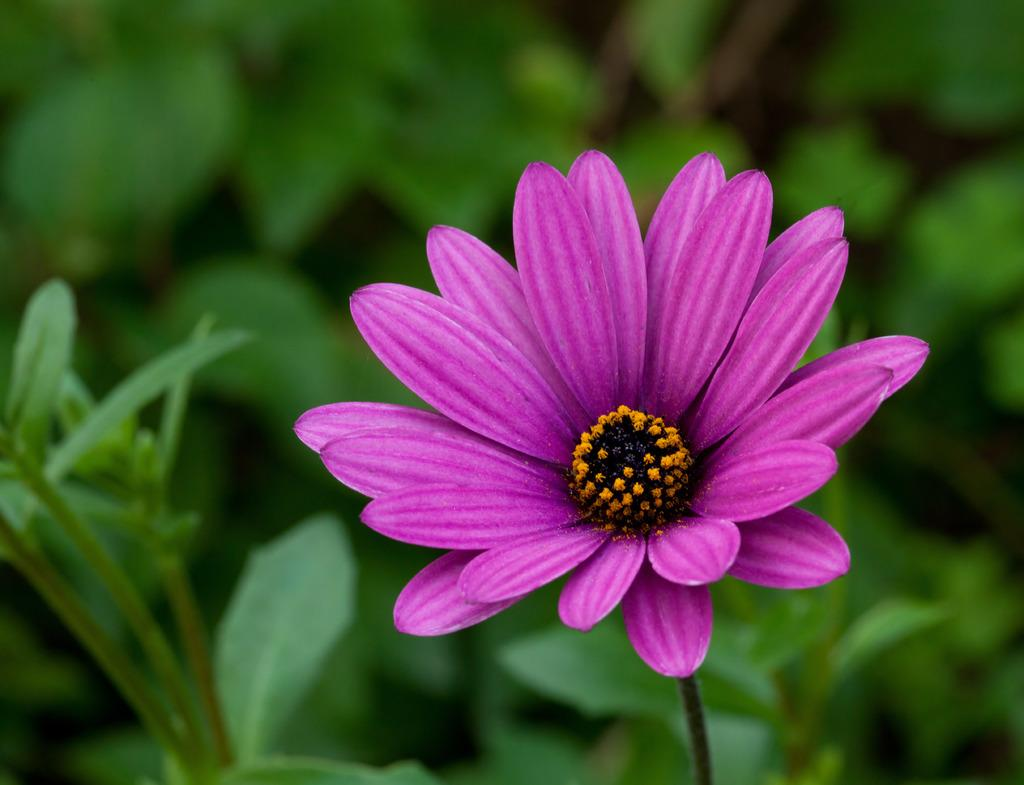What is the main subject in the foreground of the image? There is a flower in the foreground of the image. What can be seen in the background of the image? There are plants in the background of the image. What type of fruit is hanging from the flower in the image? There is no fruit hanging from the flower in the image. What level of security is present in the image? There is no mention of security or a prison in the image, so it cannot be determined from the image. 